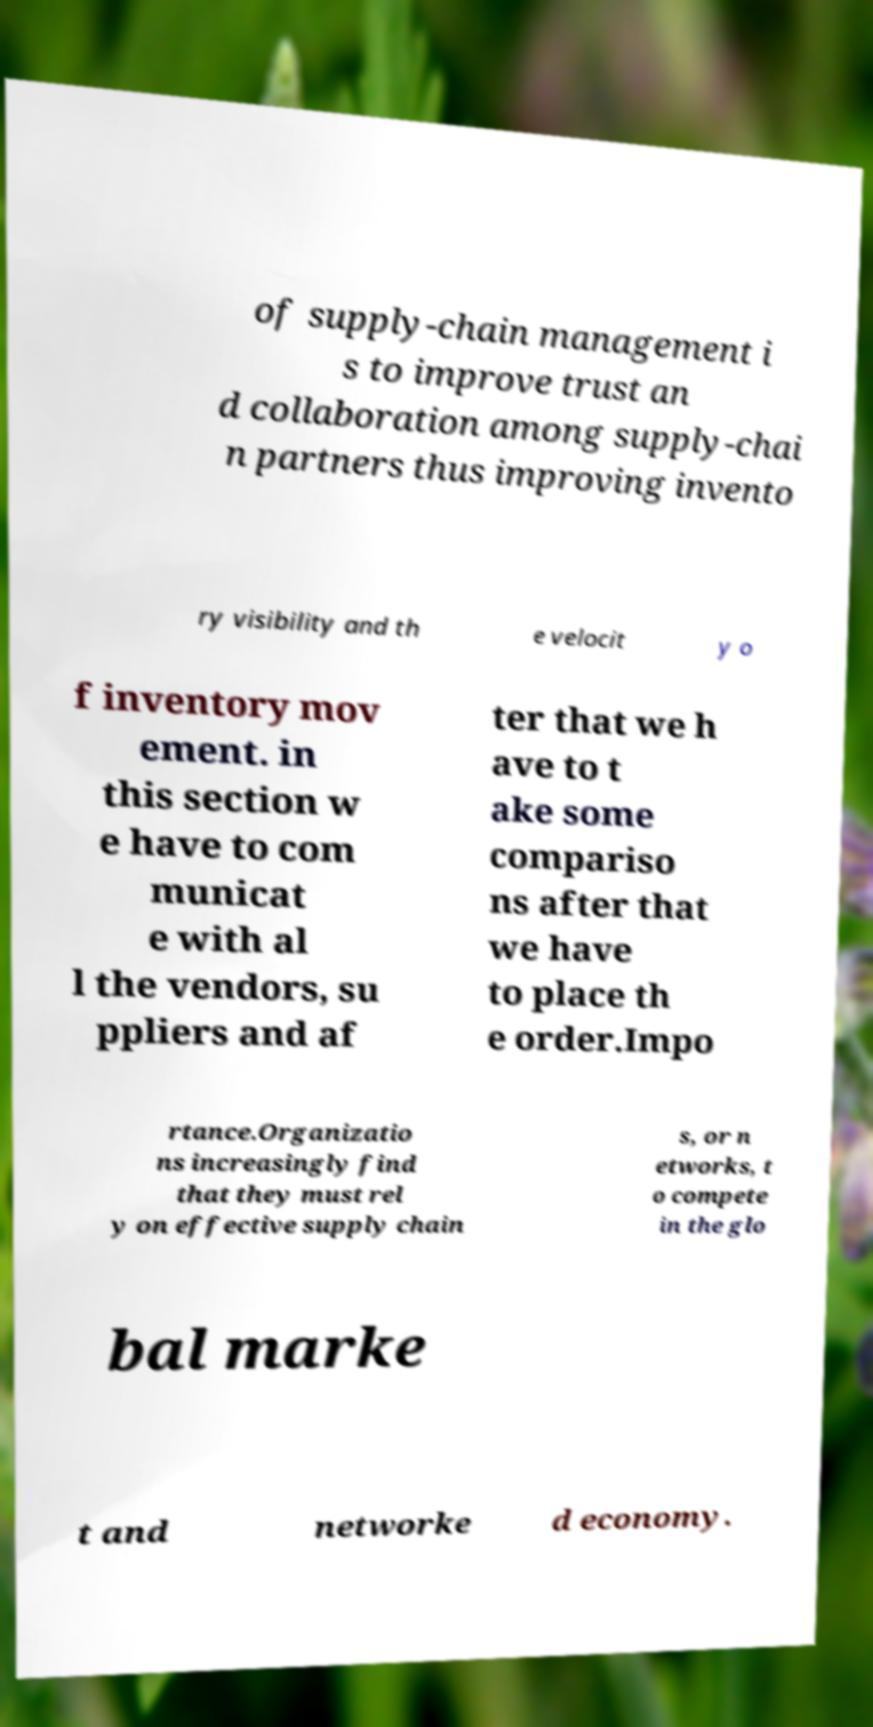Please identify and transcribe the text found in this image. of supply-chain management i s to improve trust an d collaboration among supply-chai n partners thus improving invento ry visibility and th e velocit y o f inventory mov ement. in this section w e have to com municat e with al l the vendors, su ppliers and af ter that we h ave to t ake some compariso ns after that we have to place th e order.Impo rtance.Organizatio ns increasingly find that they must rel y on effective supply chain s, or n etworks, t o compete in the glo bal marke t and networke d economy. 